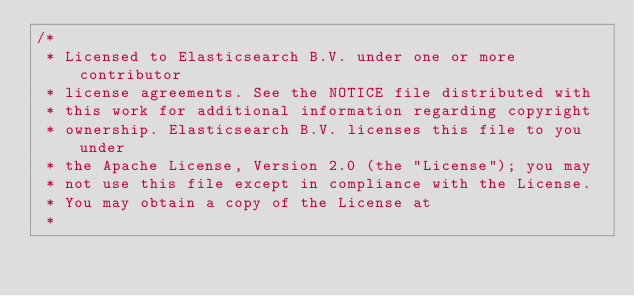Convert code to text. <code><loc_0><loc_0><loc_500><loc_500><_JavaScript_>/*
 * Licensed to Elasticsearch B.V. under one or more contributor
 * license agreements. See the NOTICE file distributed with
 * this work for additional information regarding copyright
 * ownership. Elasticsearch B.V. licenses this file to you under
 * the Apache License, Version 2.0 (the "License"); you may
 * not use this file except in compliance with the License.
 * You may obtain a copy of the License at
 *</code> 